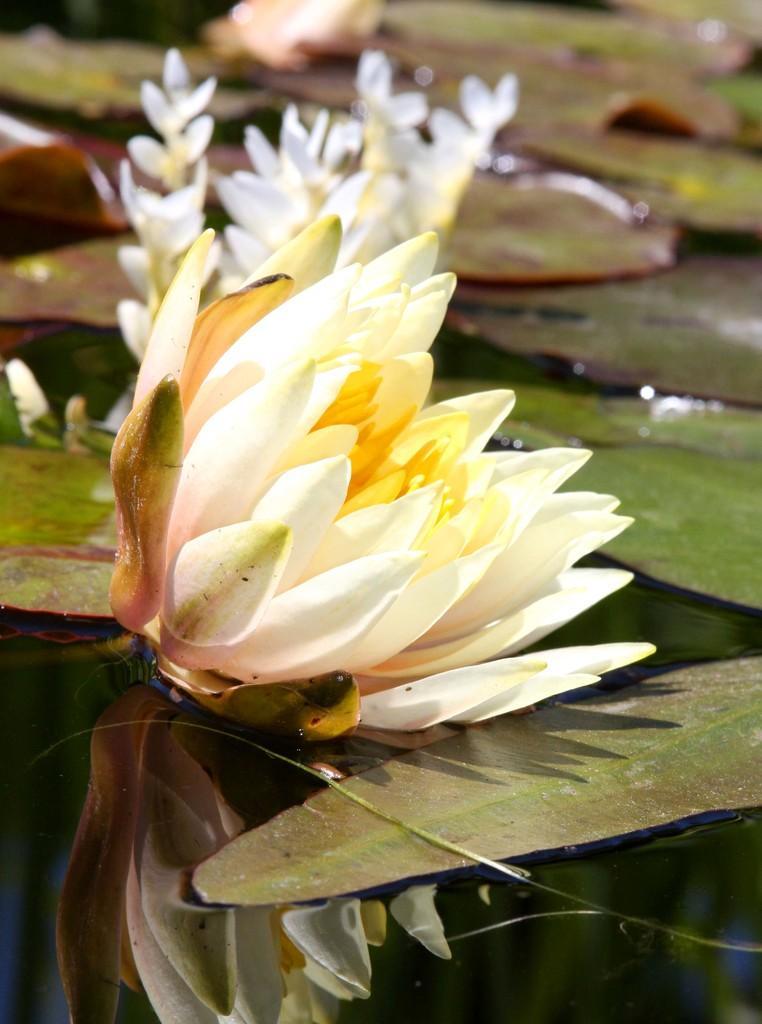Can you describe this image briefly? In this image I can see water and in it I can see few white colour flowers and few green colour leafs. I can also see this image is little bit blurry from background. 